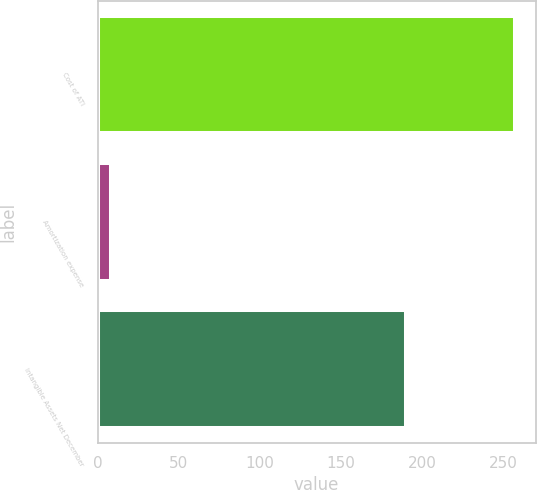Convert chart. <chart><loc_0><loc_0><loc_500><loc_500><bar_chart><fcel>Cost of ATI<fcel>Amortization expense<fcel>Intangible Assets Net December<nl><fcel>257<fcel>8<fcel>190<nl></chart> 